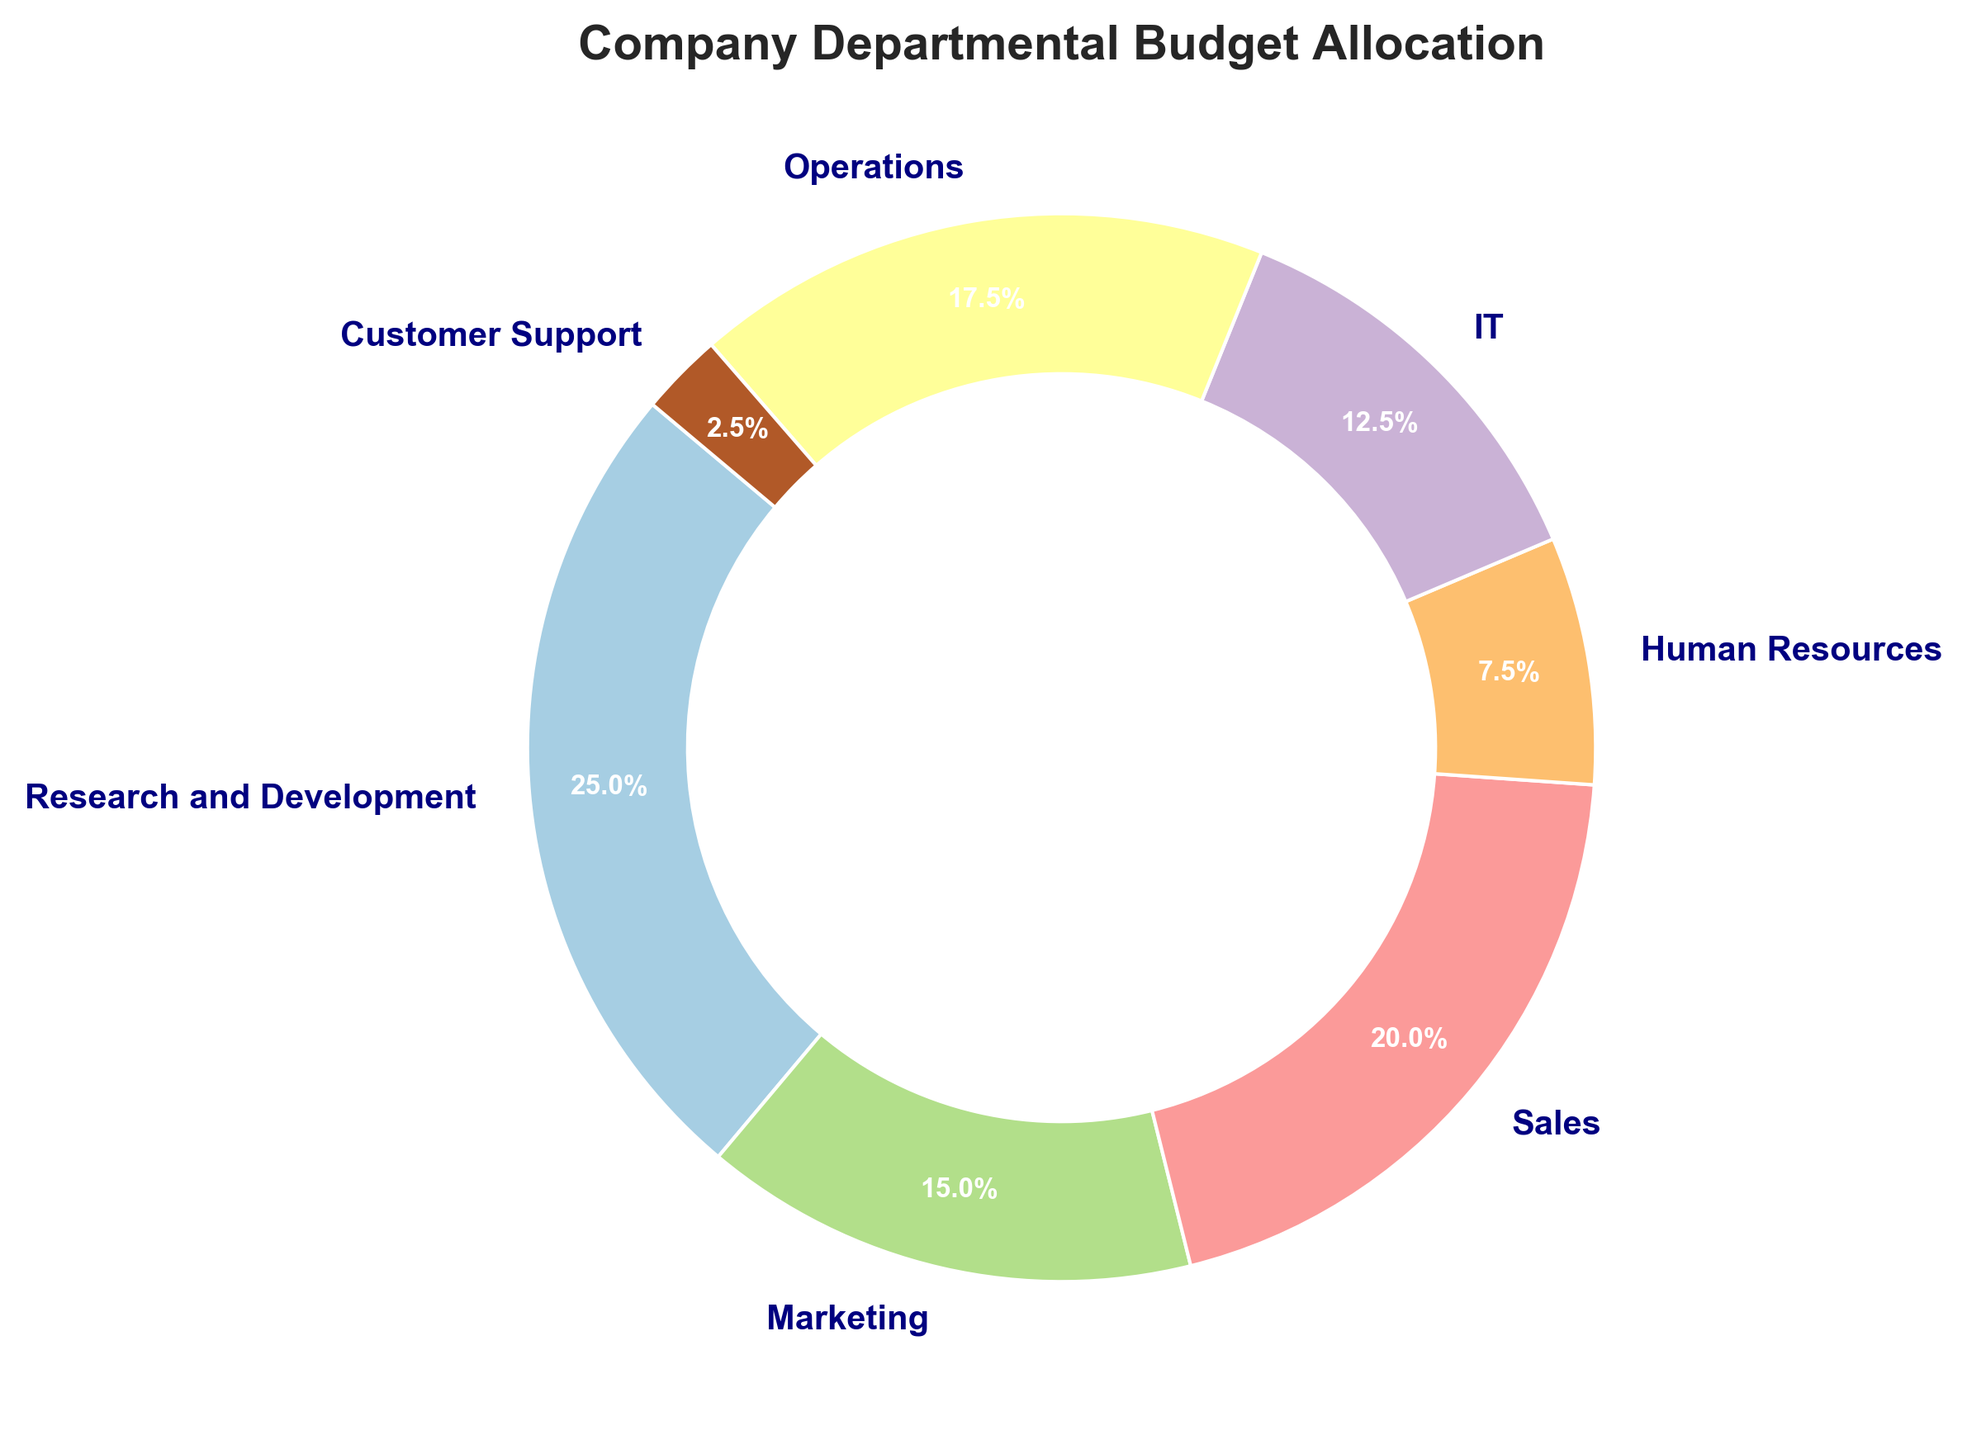What is the percentage allocation for the Sales department? The Sales department's percentage allocation is labeled directly on the ring chart as part of the visual information.
Answer: 20% Which department receives a larger budget allocation, Marketing or Operations? Compare the percentage allocations for Marketing and Operations as labeled on the chart. Marketing has 15%, whereas Operations has 17.5%.
Answer: Operations What is the total budget allocation for IT and Human Resources combined? Sum the percentage allocations for IT (12.5%) and Human Resources (7.5%). 12.5 + 7.5 = 20
Answer: 20% Which department has the smallest budget allocation, and what is its percentage? By checking the smallest labeled percentage on the ring chart, Customer Support has the smallest allocation labeled as 2.5%.
Answer: Customer Support, 2.5% How much more budget does Research and Development receive compared to Customer Support in percentage terms? Subtract the percentage of Customer Support (2.5%) from the percentage of Research and Development (25%). 25 - 2.5 = 22.5
Answer: 22.5% If the company wants to increase the IT budget to match the Operations budget, by what percentage must it increase? Operations has 17.5%, and IT has 12.5%. The difference is 17.5 - 12.5 = 5, which is the increase needed.
Answer: 5% What is the combined budget allocation for departments with allocation of 20% or more? Identify departments with 20% or more: Research and Development (25%) and Sales (20%). The combined percentage is 25 + 20 = 45
Answer: 45% Which department uses the color at the top starting from angle zero? The color starting from angle zero corresponds to the Research and Development department as it appears first in the ring chart running clockwise from the top.
Answer: Research and Development What is the average budget allocation of all departments listed? Sum all percentage allocations: 25 + 15 + 20 + 7.5 + 12.5 + 17.5 + 2.5 = 100. There are 7 departments, so the average is 100 / 7 ≈ 14.29.
Answer: ≈ 14.29 